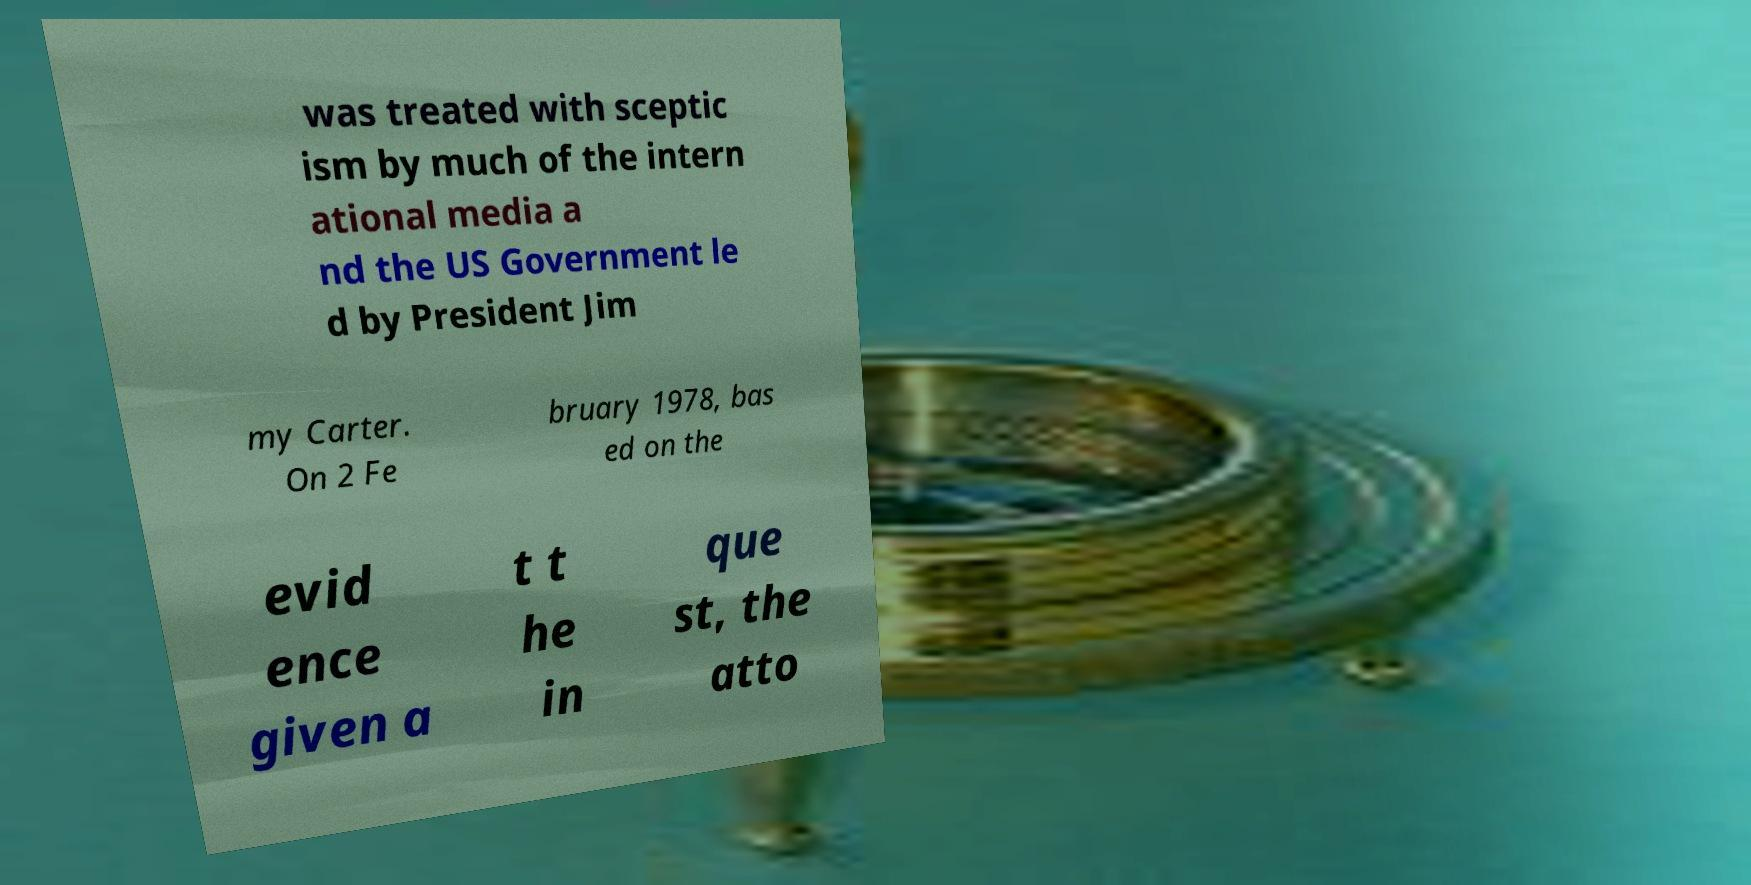There's text embedded in this image that I need extracted. Can you transcribe it verbatim? was treated with sceptic ism by much of the intern ational media a nd the US Government le d by President Jim my Carter. On 2 Fe bruary 1978, bas ed on the evid ence given a t t he in que st, the atto 